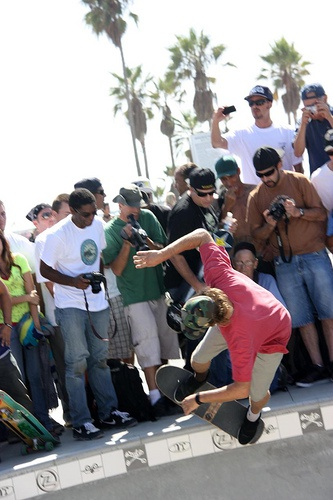Describe the objects in this image and their specific colors. I can see people in white, brown, black, and lightgray tones, people in white, black, lavender, gray, and navy tones, people in white, black, maroon, gray, and darkblue tones, people in white, black, gray, and darkgray tones, and people in white, gray, black, and teal tones in this image. 